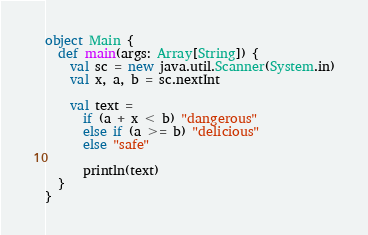Convert code to text. <code><loc_0><loc_0><loc_500><loc_500><_Scala_>
object Main {
  def main(args: Array[String]) {
    val sc = new java.util.Scanner(System.in)
    val x, a, b = sc.nextInt

    val text =
      if (a + x < b) "dangerous"
      else if (a >= b) "delicious"
      else "safe"

      println(text)
  }
}

</code> 